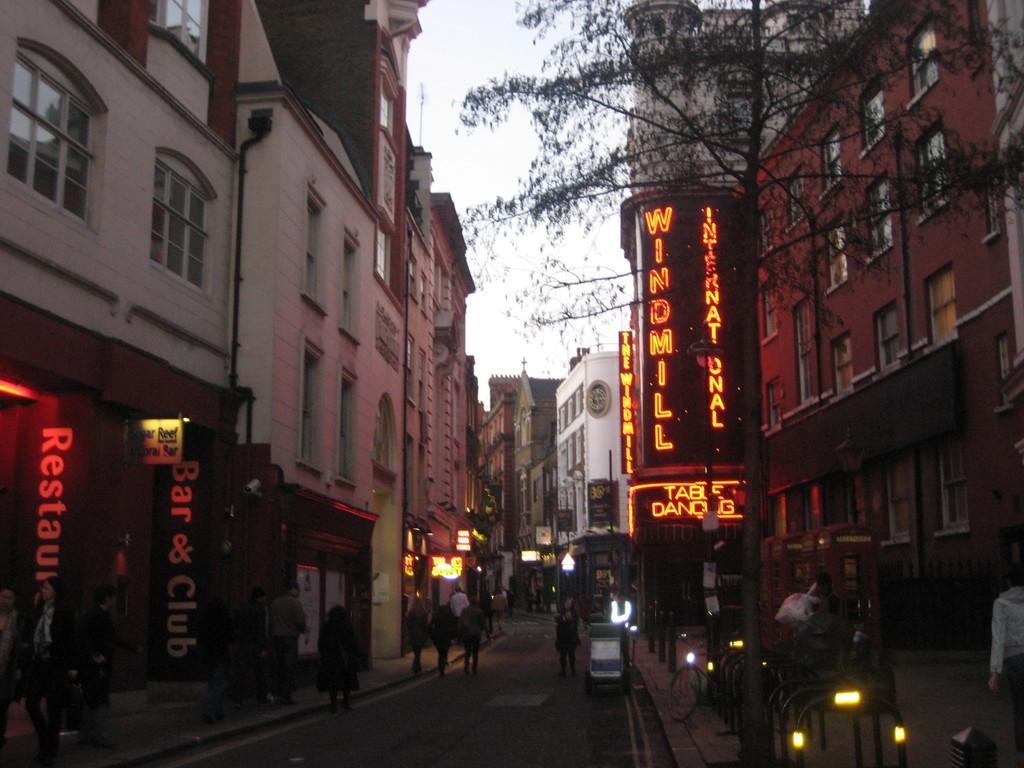Can you describe this image briefly? In this picture we can see the view of the road with some persons walking on the road. On both the side there are some buildings, shops and trees. 